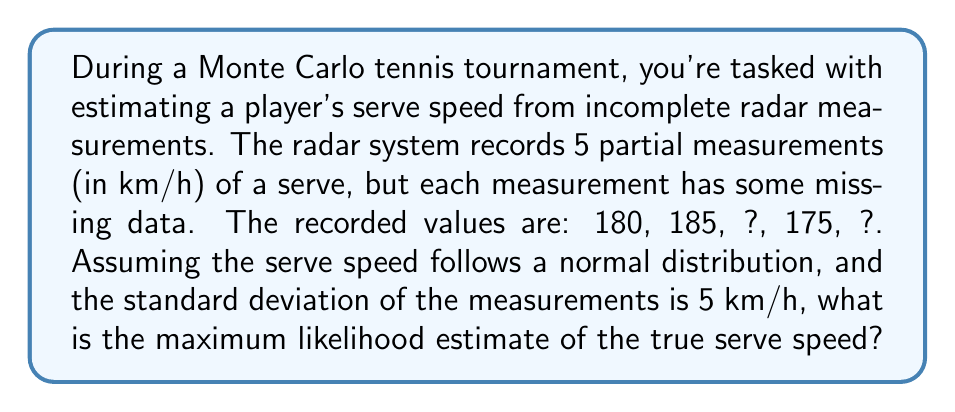Provide a solution to this math problem. To solve this problem, we'll use the maximum likelihood estimation method for a normal distribution with missing data:

1. Let's define our variables:
   $n$ = total number of measurements = 5
   $m$ = number of observed measurements = 3
   $\sigma$ = standard deviation = 5 km/h
   $x_i$ = observed measurements = {180, 185, 175}

2. The maximum likelihood estimate (MLE) for the mean $\mu$ with missing data is:

   $$\hat{\mu} = \frac{1}{m} \sum_{i=1}^m x_i$$

3. Calculate the sum of observed measurements:
   $$\sum_{i=1}^m x_i = 180 + 185 + 175 = 540$$

4. Apply the MLE formula:
   $$\hat{\mu} = \frac{540}{3} = 180$$

Therefore, the maximum likelihood estimate of the true serve speed is 180 km/h.

Note: This method assumes that the missing data is missing completely at random (MCAR). In real-world scenarios, more sophisticated methods might be needed to account for potential biases in missing data.
Answer: 180 km/h 